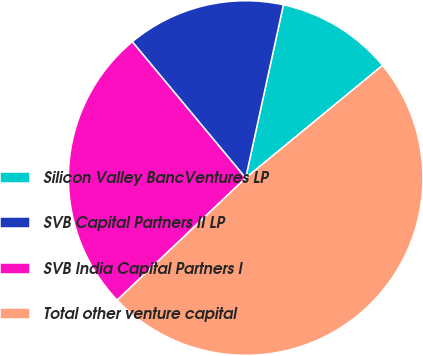Convert chart to OTSL. <chart><loc_0><loc_0><loc_500><loc_500><pie_chart><fcel>Silicon Valley BancVentures LP<fcel>SVB Capital Partners II LP<fcel>SVB India Capital Partners I<fcel>Total other venture capital<nl><fcel>10.63%<fcel>14.46%<fcel>26.05%<fcel>48.86%<nl></chart> 